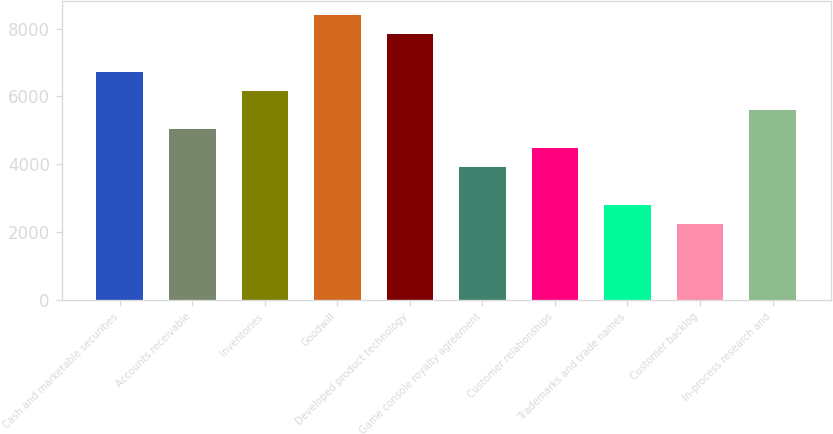<chart> <loc_0><loc_0><loc_500><loc_500><bar_chart><fcel>Cash and marketable securities<fcel>Accounts receivable<fcel>Inventories<fcel>Goodwill<fcel>Developed product technology<fcel>Game console royalty agreement<fcel>Customer relationships<fcel>Trademarks and trade names<fcel>Customer backlog<fcel>In-process research and<nl><fcel>6724.4<fcel>5043.8<fcel>6164.2<fcel>8405<fcel>7844.8<fcel>3923.4<fcel>4483.6<fcel>2803<fcel>2242.8<fcel>5604<nl></chart> 